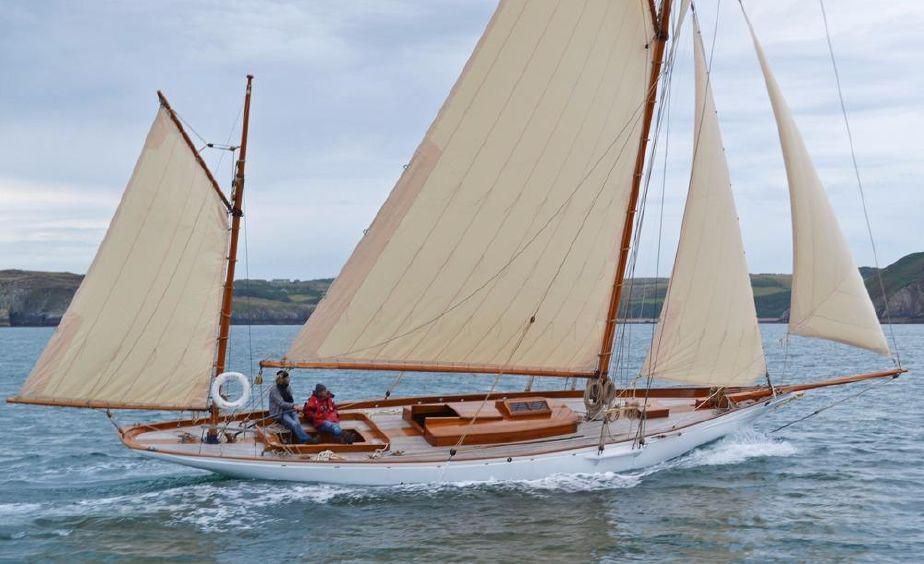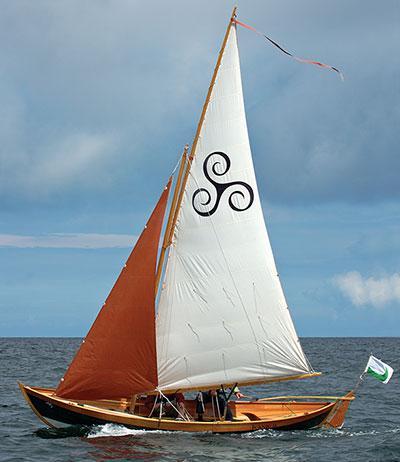The first image is the image on the left, the second image is the image on the right. Given the left and right images, does the statement "In one of the images the boat is blue." hold true? Answer yes or no. No. The first image is the image on the left, the second image is the image on the right. Evaluate the accuracy of this statement regarding the images: "In one of the images there is a green and brown boat with brown sails". Is it true? Answer yes or no. No. The first image is the image on the left, the second image is the image on the right. Evaluate the accuracy of this statement regarding the images: "One image shows a boat with a green exterior and brown sails.". Is it true? Answer yes or no. No. 